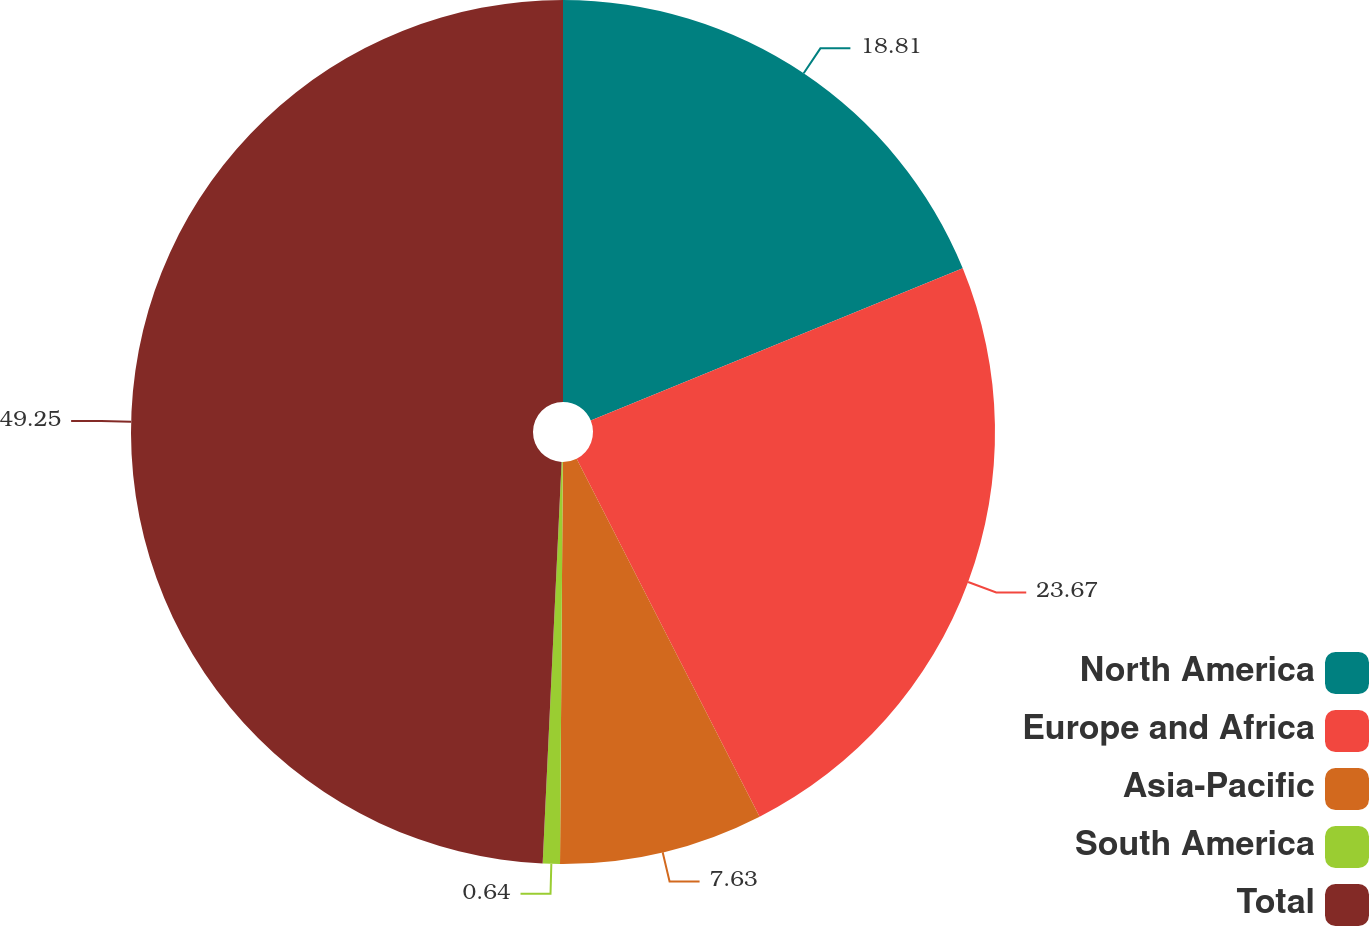<chart> <loc_0><loc_0><loc_500><loc_500><pie_chart><fcel>North America<fcel>Europe and Africa<fcel>Asia-Pacific<fcel>South America<fcel>Total<nl><fcel>18.81%<fcel>23.67%<fcel>7.63%<fcel>0.64%<fcel>49.25%<nl></chart> 